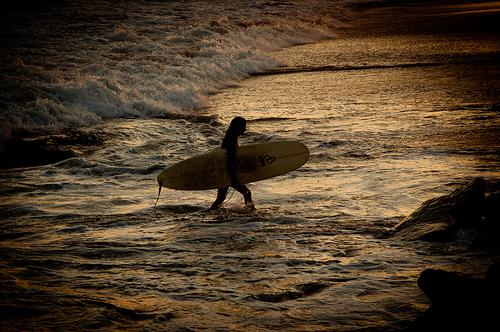Question: where is this photograph taken?
Choices:
A. At a school.
B. At the beach.
C. At the park.
D. At the store.
Answer with the letter. Answer: B Question: where is the person walking?
Choices:
A. In the street.
B. In the ocean.
C. On the sand.
D. On the grass.
Answer with the letter. Answer: B Question: when was this photo taken?
Choices:
A. Night.
B. Morning.
C. Afternoon.
D. Sunset.
Answer with the letter. Answer: D Question: what is the person carrying?
Choices:
A. A purse.
B. A backpack.
C. A surfboard.
D. A box.
Answer with the letter. Answer: C 